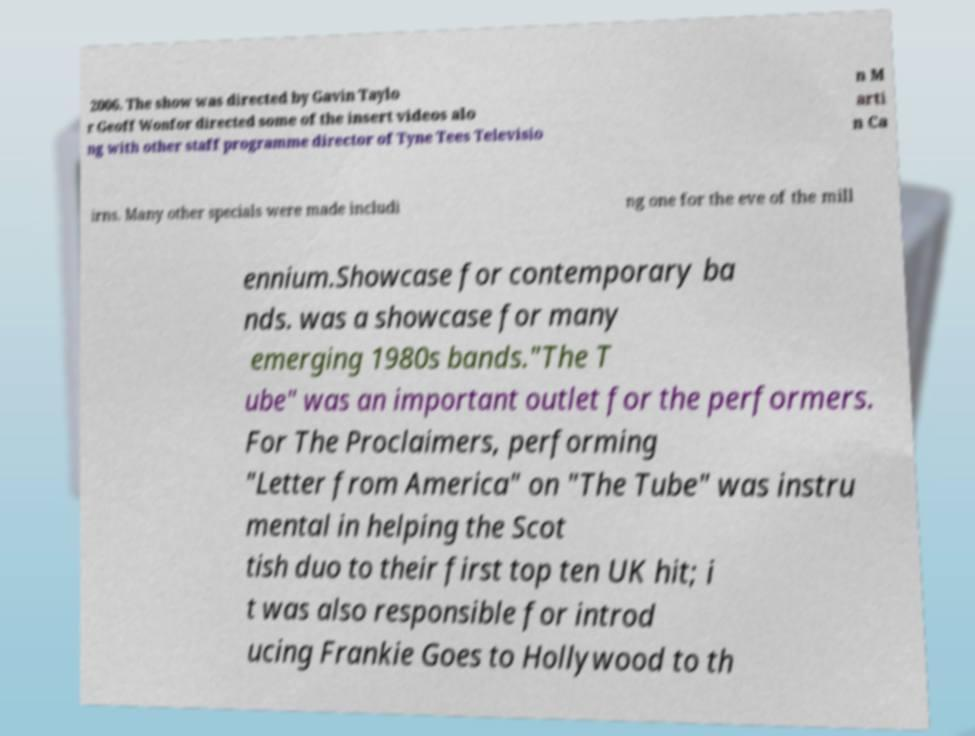Can you accurately transcribe the text from the provided image for me? 2006. The show was directed by Gavin Taylo r Geoff Wonfor directed some of the insert videos alo ng with other staff programme director of Tyne Tees Televisio n M arti n Ca irns. Many other specials were made includi ng one for the eve of the mill ennium.Showcase for contemporary ba nds. was a showcase for many emerging 1980s bands."The T ube" was an important outlet for the performers. For The Proclaimers, performing "Letter from America" on "The Tube" was instru mental in helping the Scot tish duo to their first top ten UK hit; i t was also responsible for introd ucing Frankie Goes to Hollywood to th 